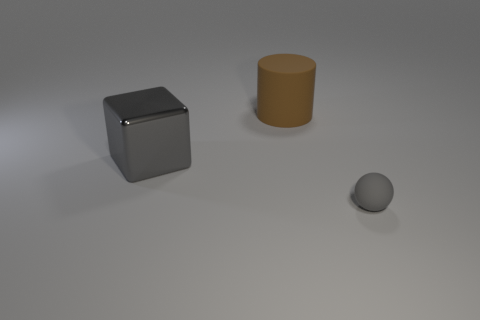Add 3 gray shiny blocks. How many objects exist? 6 Subtract all blocks. How many objects are left? 2 Subtract all blocks. Subtract all tiny gray balls. How many objects are left? 1 Add 3 large gray metal things. How many large gray metal things are left? 4 Add 3 metal things. How many metal things exist? 4 Subtract 1 brown cylinders. How many objects are left? 2 Subtract all purple balls. How many green cubes are left? 0 